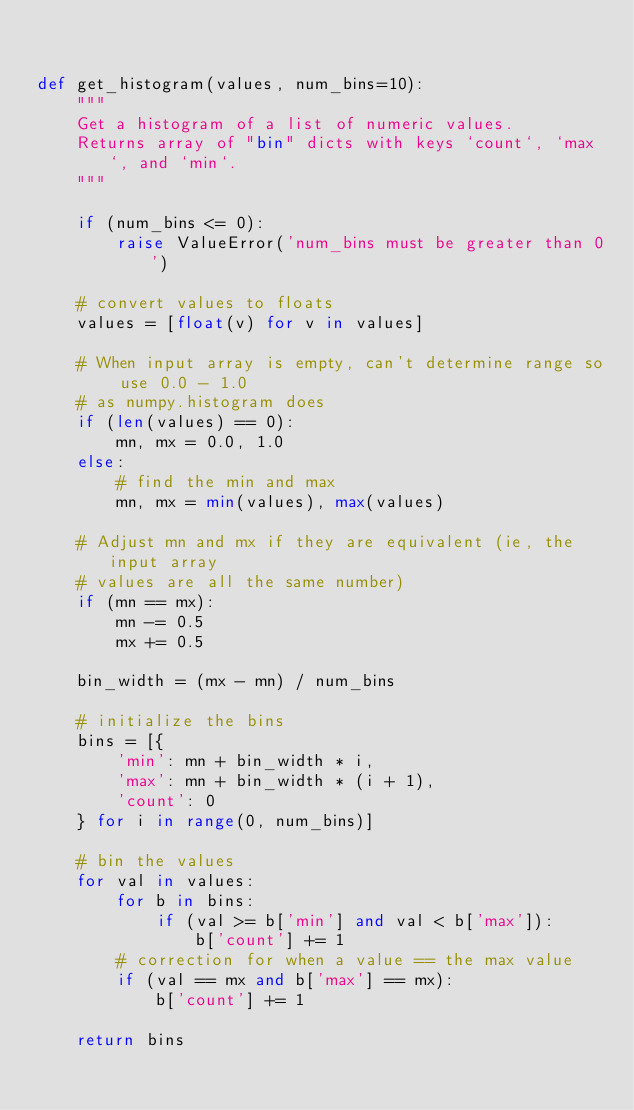Convert code to text. <code><loc_0><loc_0><loc_500><loc_500><_Python_>

def get_histogram(values, num_bins=10):
    """
    Get a histogram of a list of numeric values.
    Returns array of "bin" dicts with keys `count`, `max`, and `min`.
    """

    if (num_bins <= 0):
        raise ValueError('num_bins must be greater than 0')

    # convert values to floats
    values = [float(v) for v in values]

    # When input array is empty, can't determine range so use 0.0 - 1.0
    # as numpy.histogram does
    if (len(values) == 0):
        mn, mx = 0.0, 1.0
    else:
        # find the min and max
        mn, mx = min(values), max(values)

    # Adjust mn and mx if they are equivalent (ie, the input array
    # values are all the same number)
    if (mn == mx):
        mn -= 0.5
        mx += 0.5

    bin_width = (mx - mn) / num_bins

    # initialize the bins
    bins = [{
        'min': mn + bin_width * i,
        'max': mn + bin_width * (i + 1),
        'count': 0
    } for i in range(0, num_bins)]

    # bin the values
    for val in values:
        for b in bins:
            if (val >= b['min'] and val < b['max']):
                b['count'] += 1
        # correction for when a value == the max value
        if (val == mx and b['max'] == mx):
            b['count'] += 1

    return bins
</code> 